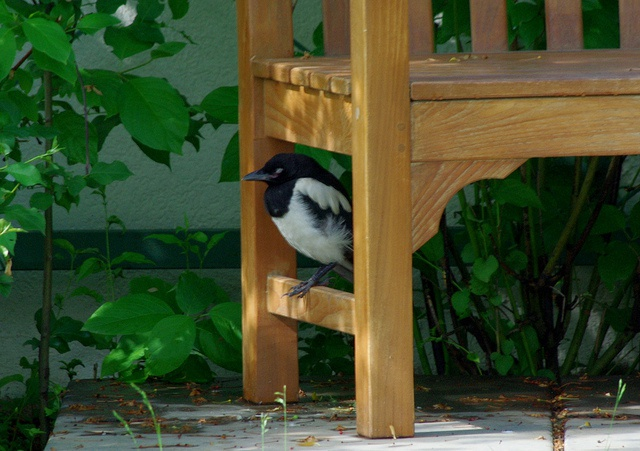Describe the objects in this image and their specific colors. I can see bench in darkgreen, olive, maroon, and black tones and bird in darkgreen, black, darkgray, and gray tones in this image. 